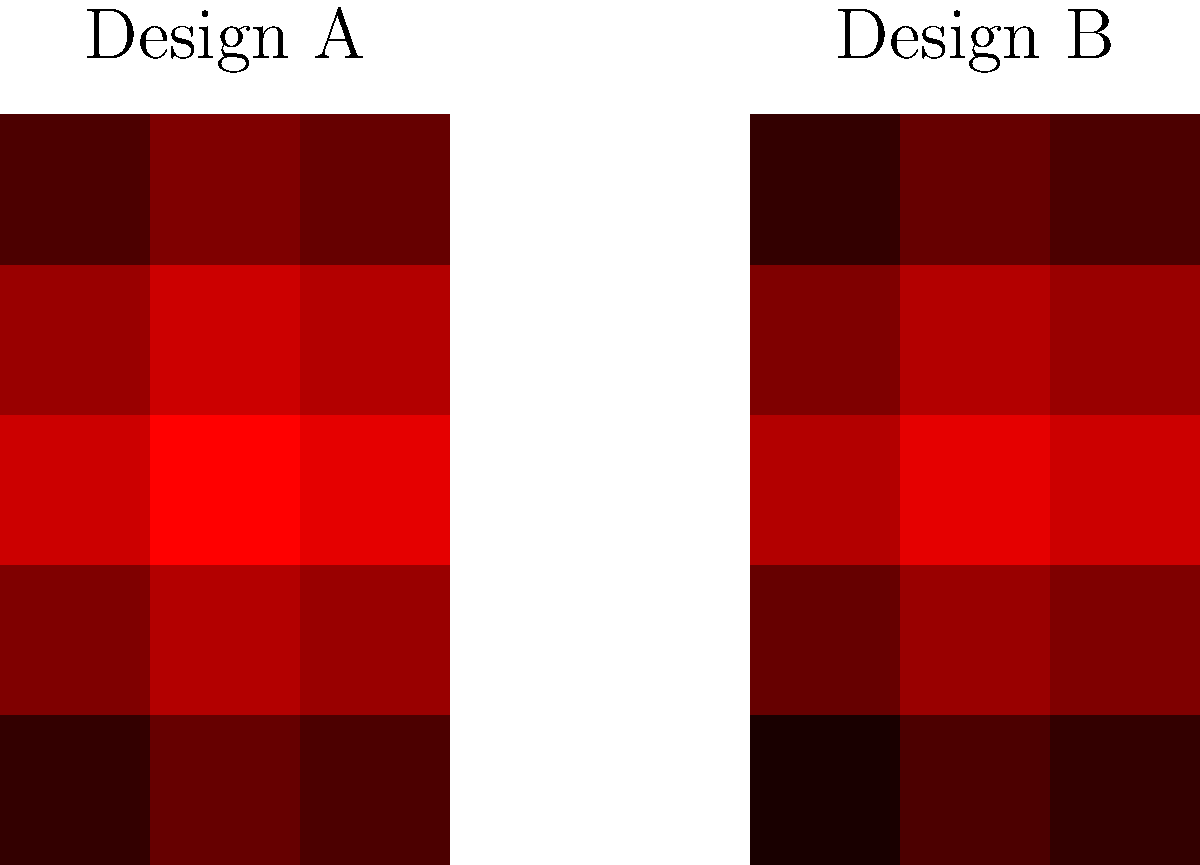As an entrepreneur in the footwear industry, you're developing a new line of walking shoes. The image shows foot pressure maps for two different shoe designs (A and B) during the stance phase of walking. Which design appears to provide better weight distribution and potentially reduce the risk of foot fatigue for long-distance walkers? To analyze the impact of shoe designs on walking gait and determine which design provides better weight distribution, we need to examine the pressure maps carefully:

1. Pressure distribution:
   - Design A shows more intense red colors, indicating higher pressure points.
   - Design B displays a more even distribution of colors, suggesting more balanced pressure across the foot.

2. High-pressure areas:
   - Design A has a concentrated high-pressure area in the middle of the foot (dark red).
   - Design B shows a more gradual transition of pressures from heel to toe.

3. Heel and toe pressure:
   - Design A appears to have higher pressure in the heel and toe areas.
   - Design B shows more moderate pressure in these regions.

4. Overall foot contact:
   - Design B seems to engage a larger area of the foot, as indicated by the wider spread of color.

5. Implications for foot fatigue:
   - More even pressure distribution (as seen in Design B) typically leads to reduced foot fatigue during long walks.
   - Concentrated high-pressure points (as in Design A) may increase the risk of discomfort and fatigue over time.

6. Biomechanical considerations:
   - Design B appears to promote a more natural roll from heel to toe, which is beneficial for walking gait.
   - The more balanced pressure in Design B suggests better shock absorption and weight distribution.

Based on these observations, Design B appears to provide better weight distribution across the foot. This more even distribution of pressure is likely to reduce the risk of foot fatigue for long-distance walkers by minimizing stress on any particular area of the foot.
Answer: Design B 